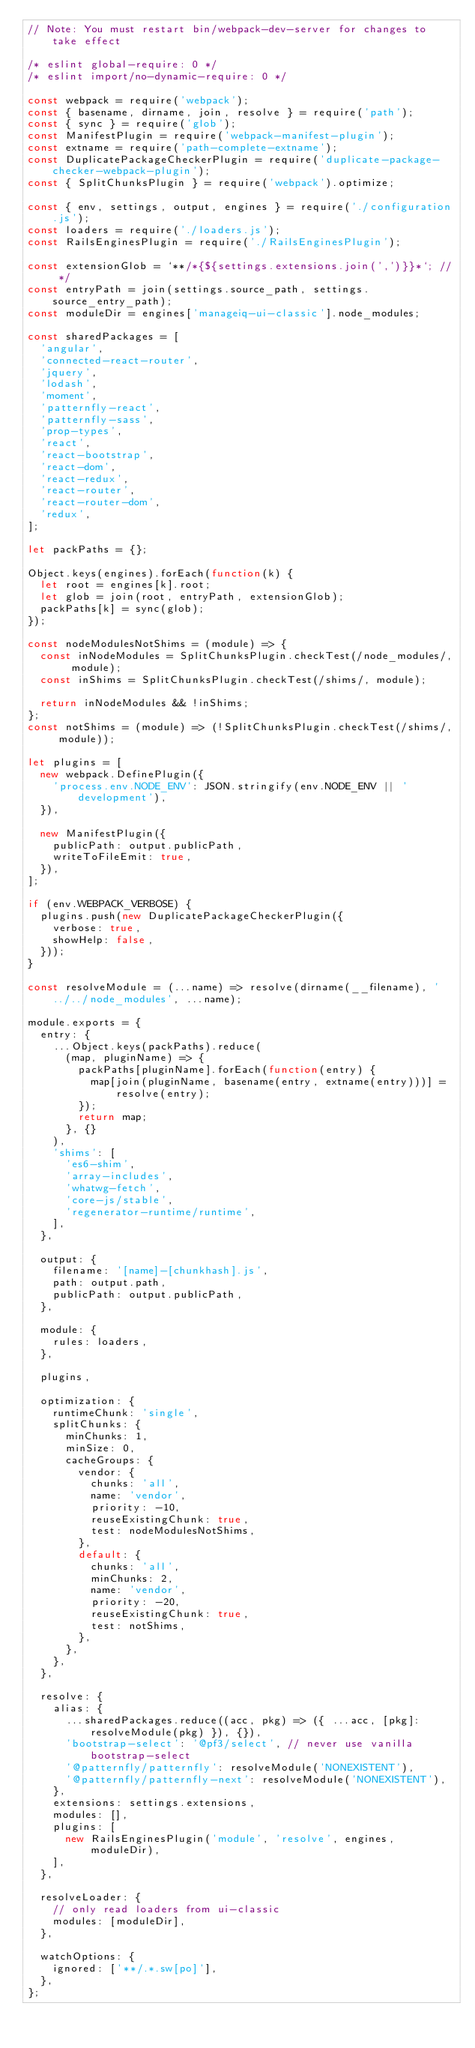<code> <loc_0><loc_0><loc_500><loc_500><_JavaScript_>// Note: You must restart bin/webpack-dev-server for changes to take effect

/* eslint global-require: 0 */
/* eslint import/no-dynamic-require: 0 */

const webpack = require('webpack');
const { basename, dirname, join, resolve } = require('path');
const { sync } = require('glob');
const ManifestPlugin = require('webpack-manifest-plugin');
const extname = require('path-complete-extname');
const DuplicatePackageCheckerPlugin = require('duplicate-package-checker-webpack-plugin');
const { SplitChunksPlugin } = require('webpack').optimize;

const { env, settings, output, engines } = require('./configuration.js');
const loaders = require('./loaders.js');
const RailsEnginesPlugin = require('./RailsEnginesPlugin');

const extensionGlob = `**/*{${settings.extensions.join(',')}}*`; // */
const entryPath = join(settings.source_path, settings.source_entry_path);
const moduleDir = engines['manageiq-ui-classic'].node_modules;

const sharedPackages = [
  'angular',
  'connected-react-router',
  'jquery',
  'lodash',
  'moment',
  'patternfly-react',
  'patternfly-sass',
  'prop-types',
  'react',
  'react-bootstrap',
  'react-dom',
  'react-redux',
  'react-router',
  'react-router-dom',
  'redux',
];

let packPaths = {};

Object.keys(engines).forEach(function(k) {
  let root = engines[k].root;
  let glob = join(root, entryPath, extensionGlob);
  packPaths[k] = sync(glob);
});

const nodeModulesNotShims = (module) => {
  const inNodeModules = SplitChunksPlugin.checkTest(/node_modules/, module);
  const inShims = SplitChunksPlugin.checkTest(/shims/, module);

  return inNodeModules && !inShims;
};
const notShims = (module) => (!SplitChunksPlugin.checkTest(/shims/, module));

let plugins = [
  new webpack.DefinePlugin({
    'process.env.NODE_ENV': JSON.stringify(env.NODE_ENV || 'development'),
  }),

  new ManifestPlugin({
    publicPath: output.publicPath,
    writeToFileEmit: true,
  }),
];

if (env.WEBPACK_VERBOSE) {
  plugins.push(new DuplicatePackageCheckerPlugin({
    verbose: true,
    showHelp: false,
  }));
}

const resolveModule = (...name) => resolve(dirname(__filename), '../../node_modules', ...name);

module.exports = {
  entry: {
    ...Object.keys(packPaths).reduce(
      (map, pluginName) => {
        packPaths[pluginName].forEach(function(entry) {
          map[join(pluginName, basename(entry, extname(entry)))] = resolve(entry);
        });
        return map;
      }, {}
    ),
    'shims': [
      'es6-shim',
      'array-includes',
      'whatwg-fetch',
      'core-js/stable',
      'regenerator-runtime/runtime',
    ],
  },

  output: {
    filename: '[name]-[chunkhash].js',
    path: output.path,
    publicPath: output.publicPath,
  },

  module: {
    rules: loaders,
  },

  plugins,

  optimization: {
    runtimeChunk: 'single',
    splitChunks: {
      minChunks: 1,
      minSize: 0,
      cacheGroups: {
        vendor: {
          chunks: 'all',
          name: 'vendor',
          priority: -10,
          reuseExistingChunk: true,
          test: nodeModulesNotShims,
        },
        default: {
          chunks: 'all',
          minChunks: 2,
          name: 'vendor',
          priority: -20,
          reuseExistingChunk: true,
          test: notShims,
        },
      },
    },
  },

  resolve: {
    alias: {
      ...sharedPackages.reduce((acc, pkg) => ({ ...acc, [pkg]: resolveModule(pkg) }), {}),
      'bootstrap-select': '@pf3/select', // never use vanilla bootstrap-select
      '@patternfly/patternfly': resolveModule('NONEXISTENT'),
      '@patternfly/patternfly-next': resolveModule('NONEXISTENT'),
    },
    extensions: settings.extensions,
    modules: [],
    plugins: [
      new RailsEnginesPlugin('module', 'resolve', engines, moduleDir),
    ],
  },

  resolveLoader: {
    // only read loaders from ui-classic
    modules: [moduleDir],
  },

  watchOptions: {
    ignored: ['**/.*.sw[po]'],
  },
};
</code> 